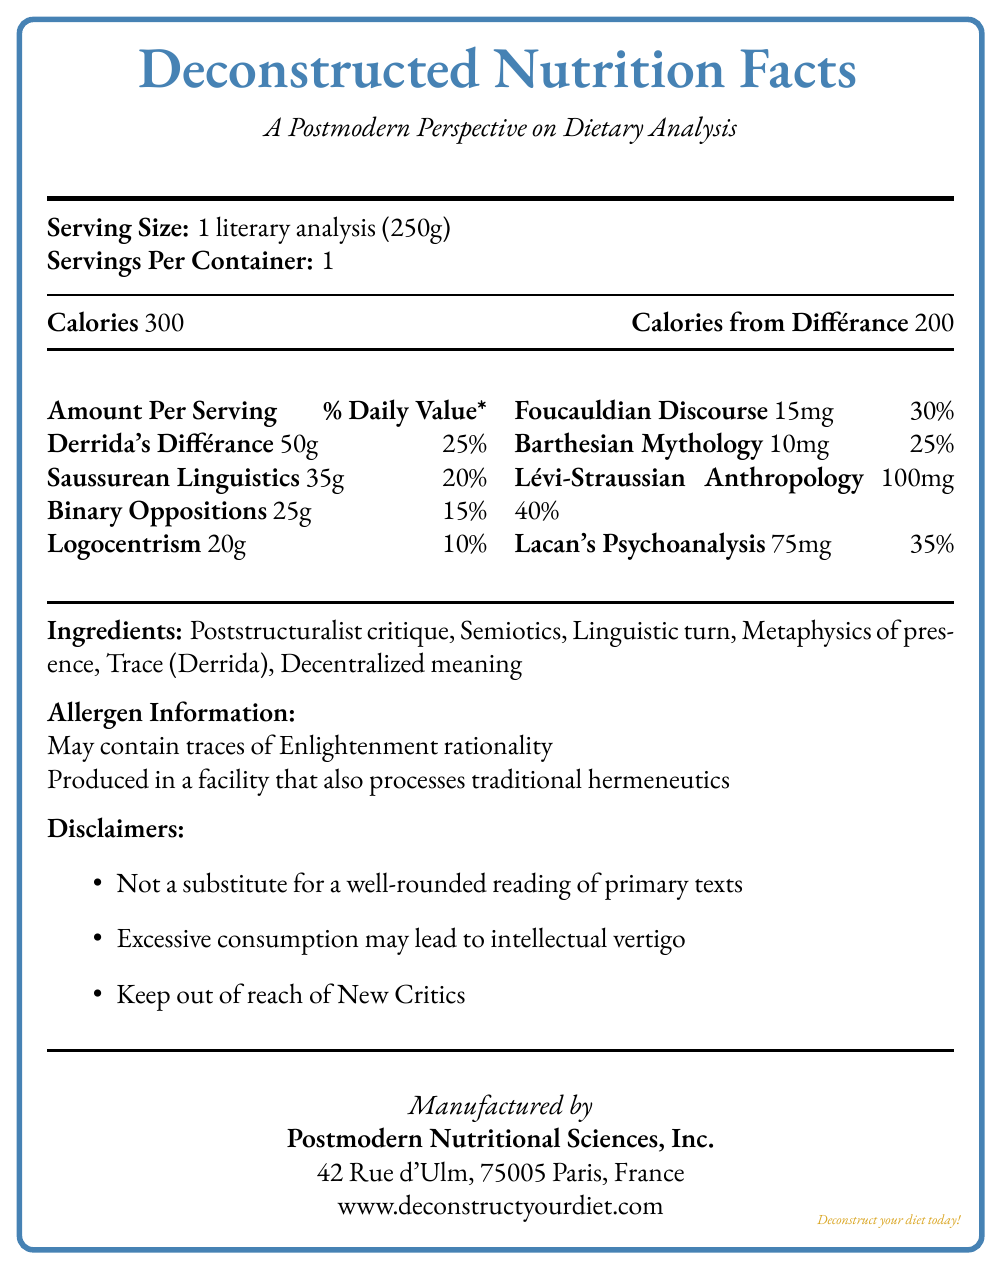what is the serving size? The serving size is clearly listed at the beginning of the document as "1 literary analysis (250g)".
Answer: 1 literary analysis (250g) how many calories are there per serving? The number of calories per serving is stated in the Calories section: "Calories 300".
Answer: 300 which nutrient has the highest daily value percentage? The Lévi-Straussian Anthropology nutrient has a daily value of 40%, which is the highest value listed.
Answer: Lévi-Straussian Anthropology list two ingredients in this deconstructed diet. The Ingredient section lists multiple items, including Poststructuralist critique and Semiotics.
Answer: Poststructuralist critique, Semiotics what might excessive consumption of this deconstructed diet lead to? One of the disclaimers mentions that excessive consumption may lead to intellectual vertigo.
Answer: Intellectual vertigo which of the following is part of the deconstructed dietary analysis? A. Freud's Psychoanalysis B. Lacan's Psychoanalysis C. Marx's Theory The nutritional label under the minerals section lists Lacan's Psychoanalysis with 35% daily value.
Answer: B. Lacan's Psychoanalysis what is the address of the manufacturer? The manufacturer's address is provided at the end of the document.
Answer: 42 Rue d'Ulm, 75005 Paris, France is it suitable for people only interested in New Criticism? One of the disclaimers states to "Keep out of reach of New Critics," suggesting it is not suitable for them.
Answer: No pick the correct allergen warning for this diet: I. May contain traces of Metaphysics of presence II. Produced in a facility that also processes traditional hermeneutics III. May contain traces of Enlightenment rationality Allergen information states: "May contain traces of Enlightenment rationality" and "Produced in a facility that also processes traditional hermeneutics".
Answer: III. May contain traces of Enlightenment rationality summarize the main purpose of this document The document is a creative take on a Nutrition Facts label reimagined through the lens of literary theory, particularly focusing on elements of structuralism and post-structuralism.
Answer: This document provides a deconstructed "Nutrition Facts" label for a literary analysis diet, using structuralist and post-structuralist concepts as nutrients, ingredients, and elements, while also humorously including disclaimers and allergen information typically found on actual food products. how many servings are there per container? The section "Servings Per Container" clearly mentions that there is 1 serving per container.
Answer: 1 what percentage of daily value is provided by Saussurean Linguistics? Saussurean Linguistics provides 20% of the daily value, as indicated under the nutrients section.
Answer: 20% can you determine the publication date of this document? The document does not contain any information regarding the date of publication.
Answer: Not enough information 